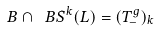<formula> <loc_0><loc_0><loc_500><loc_500>B \cap \ B S ^ { k } ( L ) = ( T ^ { g } _ { - } ) _ { k }</formula> 